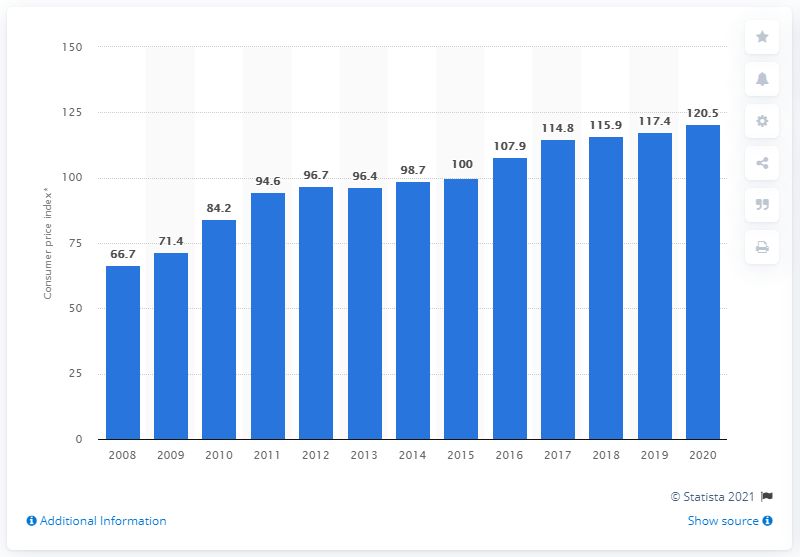Indicate a few pertinent items in this graphic. In 2020, the annual average price index value of insurance was approximately 120.5. 